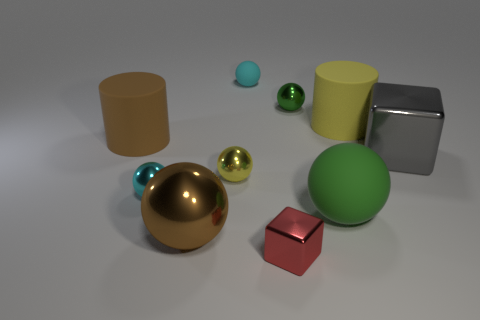Subtract all metallic spheres. How many spheres are left? 2 Subtract 3 balls. How many balls are left? 3 Add 1 small red shiny cubes. How many small red shiny cubes are left? 2 Add 3 large green things. How many large green things exist? 4 Subtract all yellow cylinders. How many cylinders are left? 1 Subtract 0 cyan cylinders. How many objects are left? 10 Subtract all cylinders. How many objects are left? 8 Subtract all green cylinders. Subtract all brown cubes. How many cylinders are left? 2 Subtract all yellow blocks. How many yellow cylinders are left? 1 Subtract all cyan metal spheres. Subtract all big yellow rubber objects. How many objects are left? 8 